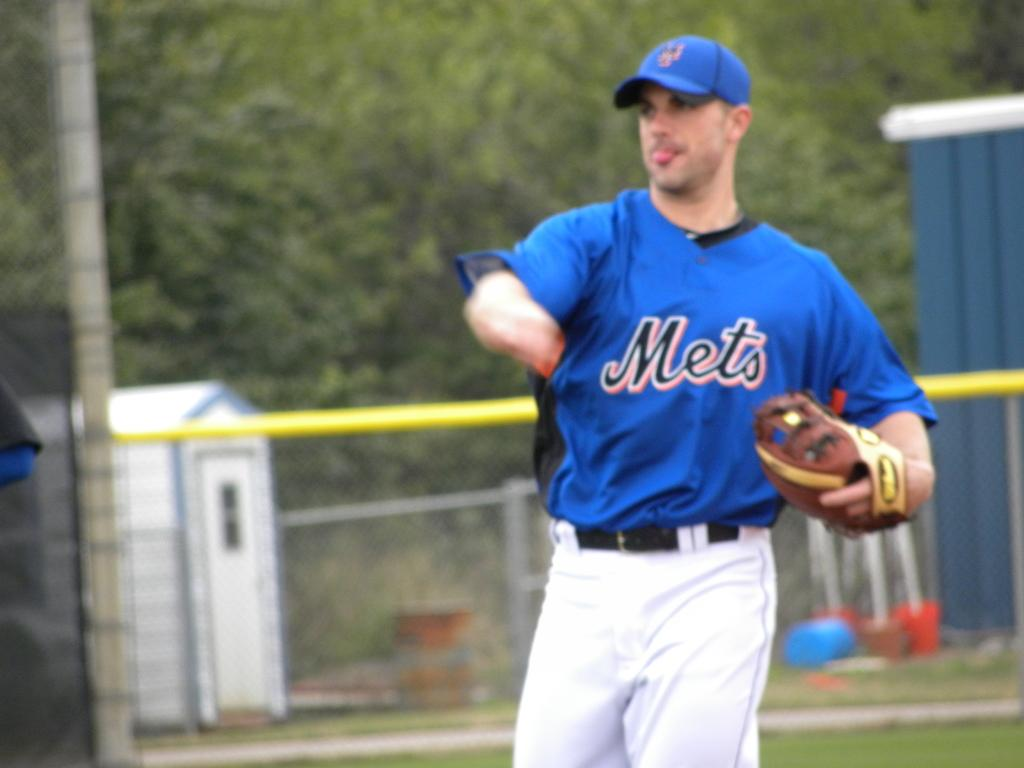<image>
Share a concise interpretation of the image provided. A man in a Mets shirt plays baseball 